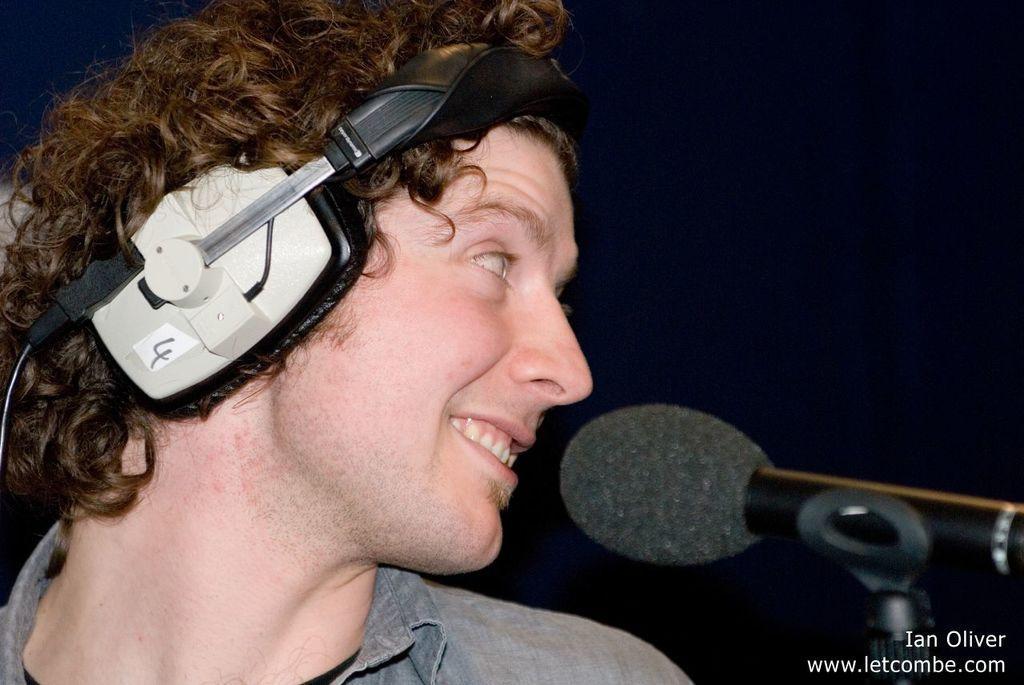How would you summarize this image in a sentence or two? In the picture we can see a man turning to the left hand side and smiling, he is with a headset and in front of him we can see the microphone to the stand. 